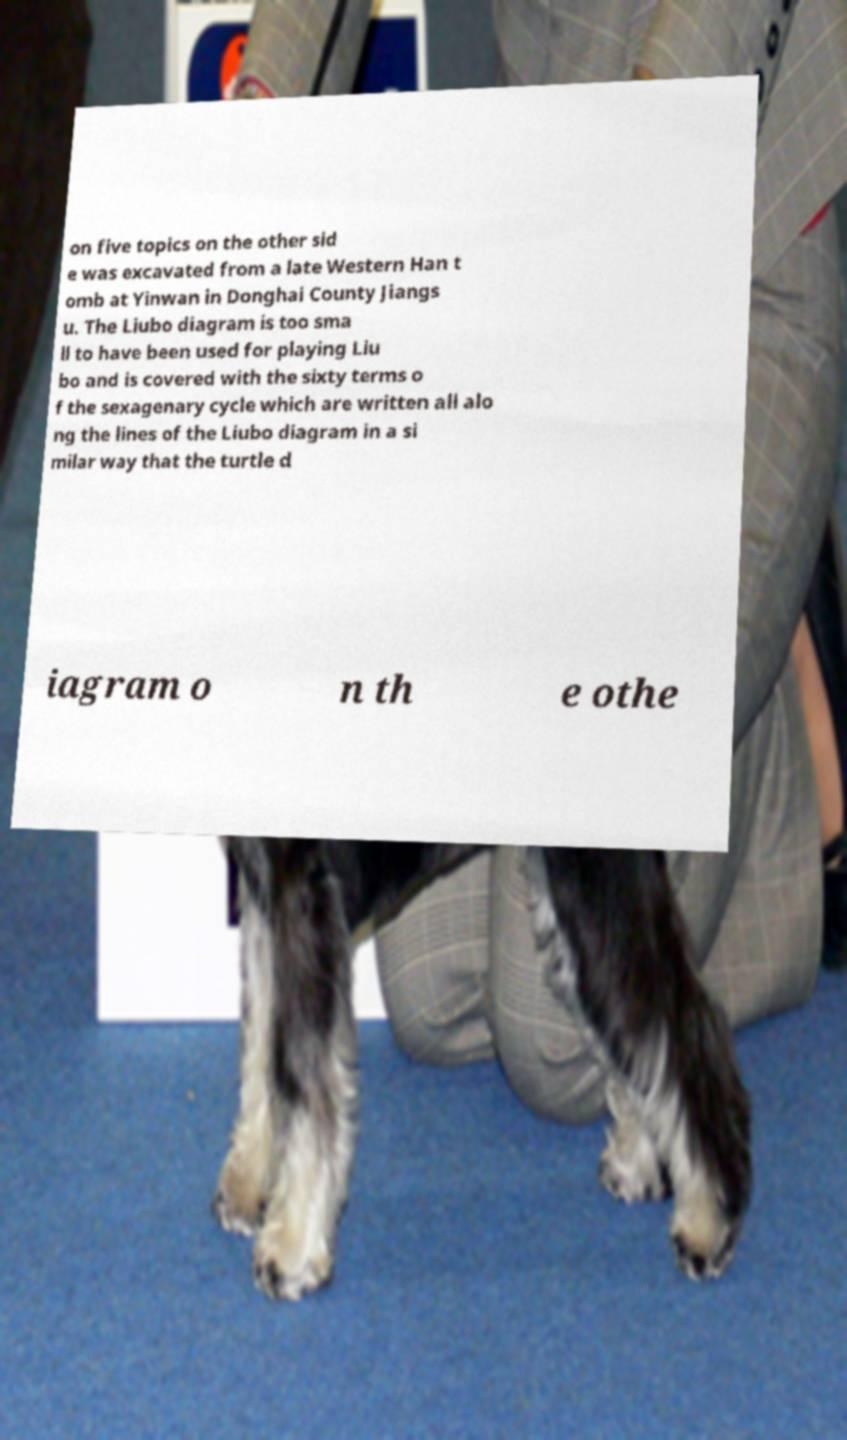I need the written content from this picture converted into text. Can you do that? on five topics on the other sid e was excavated from a late Western Han t omb at Yinwan in Donghai County Jiangs u. The Liubo diagram is too sma ll to have been used for playing Liu bo and is covered with the sixty terms o f the sexagenary cycle which are written all alo ng the lines of the Liubo diagram in a si milar way that the turtle d iagram o n th e othe 